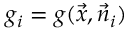Convert formula to latex. <formula><loc_0><loc_0><loc_500><loc_500>g _ { i } = g ( \vec { x } , \vec { n } _ { i } )</formula> 